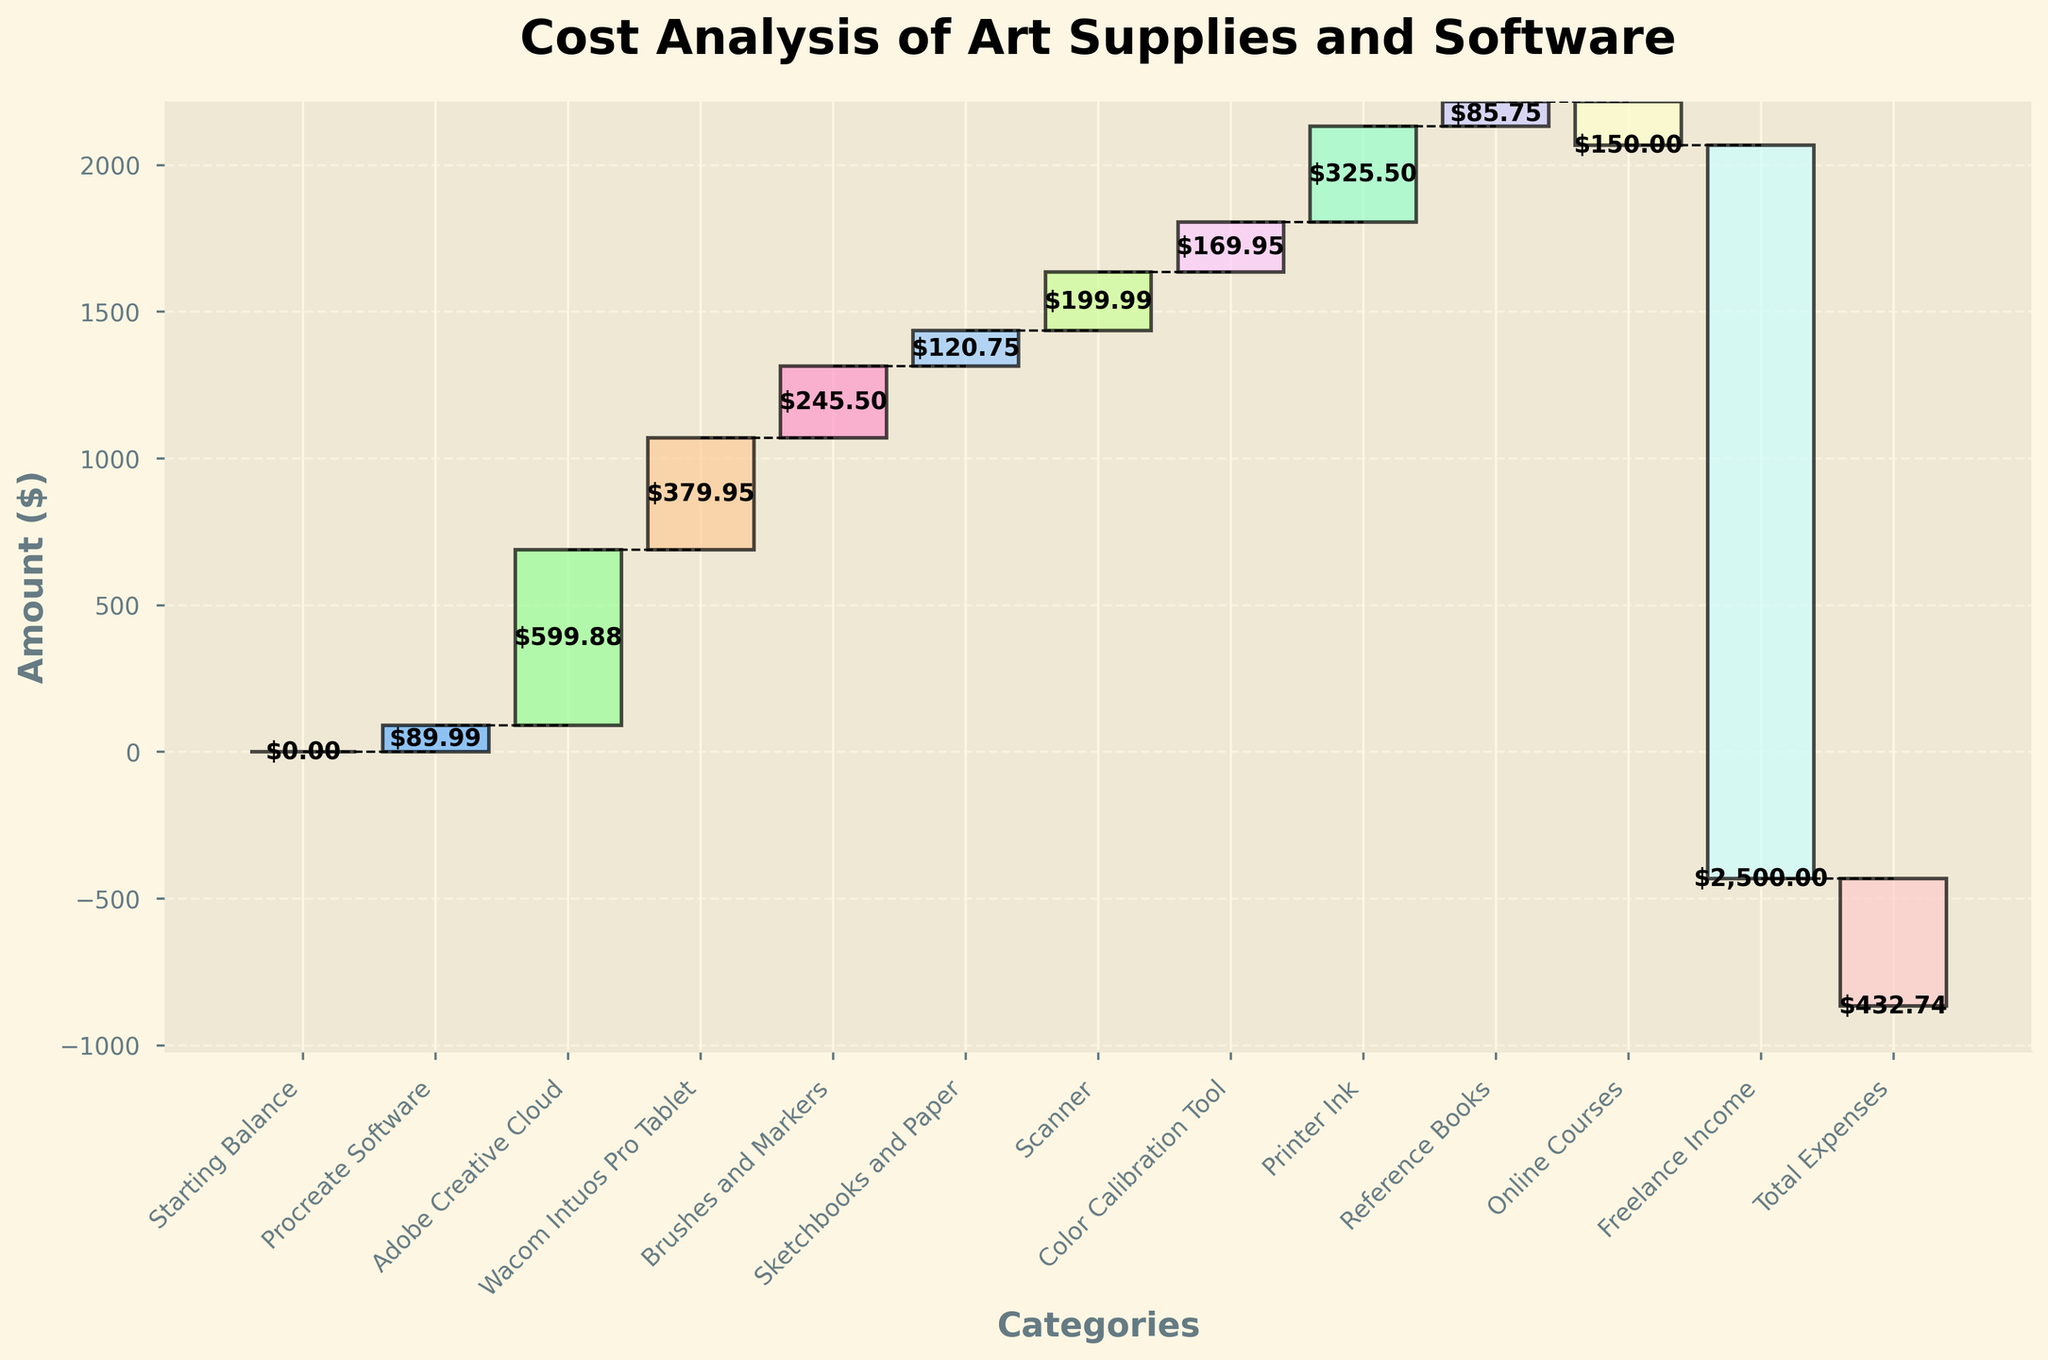What's the total expense for Brushes and Markers? Find the bar labeled "Brushes and Markers" and check the value associated with it in the chart.
Answer: $245.50 What's the title of the chart? The title is generally displayed at the top of the chart. Here, it's "Cost Analysis of Art Supplies and Software".
Answer: Cost Analysis of Art Supplies and Software Which category incurred the highest cost? Compare the heights of all positive-value bars to find the tallest one. The "Adobe Creative Cloud" bar is the tallest.
Answer: Adobe Creative Cloud How much did the Wacom Intuos Pro Tablet cost? Locate the bar labeled "Wacom Intuos Pro Tablet" and read the value displayed.
Answer: $379.95 What's the cumulative expense after the purchase of the Scanner? Find the cumulative sum position right after the bar labeled "Scanner". Sum the values up to that point.
Answer: $1,635.06 Which items saved the most money (negative values)? Locate and compare the bars with negative values. The "Freelance Income" bar is the most significant negative bar.
Answer: Freelance Income What's the total expense for software-related costs? Sum the values of "Procreate Software" and "Adobe Creative Cloud".
Answer: $689.87 Which item has the lowest cost among the listed expenses? Identify the shortest positive-value bar. The "Reference Books" bar is the shortest.
Answer: Reference Books What's the net total expense for all the art supplies and software combined? Sum all the values from the chart including negative values. The total expense is equal to the final value shown.
Answer: -$432.74 